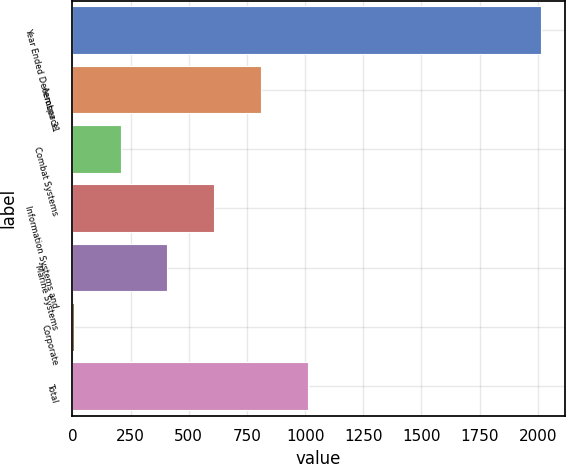<chart> <loc_0><loc_0><loc_500><loc_500><bar_chart><fcel>Year Ended December 31<fcel>Aerospace<fcel>Combat Systems<fcel>Information Systems and<fcel>Marine Systems<fcel>Corporate<fcel>Total<nl><fcel>2015<fcel>810.2<fcel>207.8<fcel>609.4<fcel>408.6<fcel>7<fcel>1011<nl></chart> 